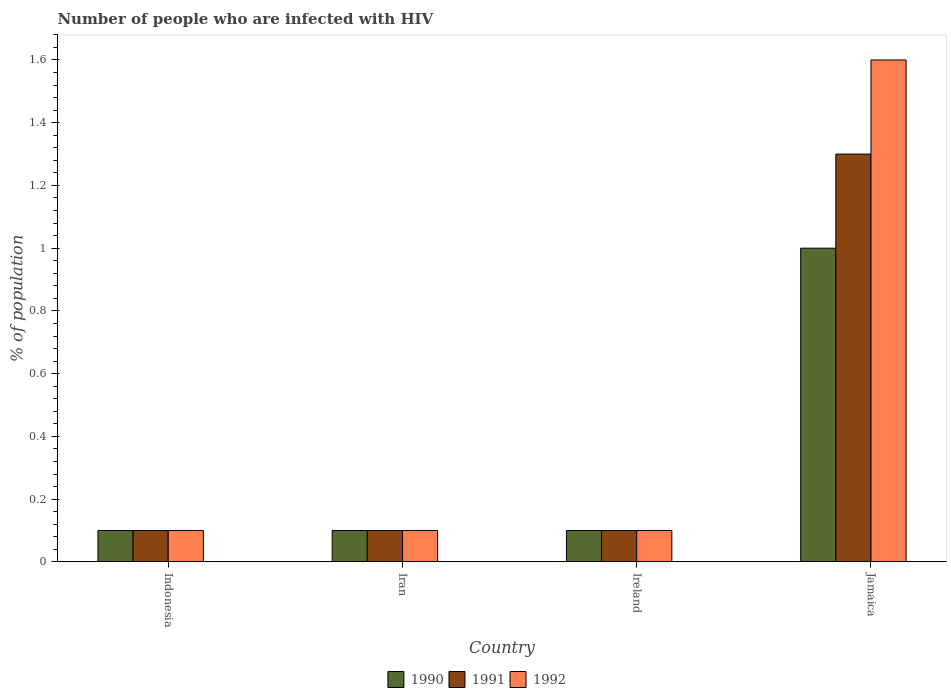How many different coloured bars are there?
Ensure brevity in your answer.  3. How many bars are there on the 4th tick from the right?
Ensure brevity in your answer.  3. What is the label of the 4th group of bars from the left?
Provide a short and direct response. Jamaica. In how many cases, is the number of bars for a given country not equal to the number of legend labels?
Offer a very short reply. 0. Across all countries, what is the minimum percentage of HIV infected population in in 1990?
Provide a succinct answer. 0.1. In which country was the percentage of HIV infected population in in 1992 maximum?
Provide a short and direct response. Jamaica. What is the total percentage of HIV infected population in in 1990 in the graph?
Offer a very short reply. 1.3. What is the difference between the percentage of HIV infected population in in 1991 in Ireland and the percentage of HIV infected population in in 1992 in Indonesia?
Your answer should be compact. 0. What is the average percentage of HIV infected population in in 1991 per country?
Your answer should be very brief. 0.4. What is the difference between the percentage of HIV infected population in of/in 1992 and percentage of HIV infected population in of/in 1990 in Indonesia?
Ensure brevity in your answer.  0. In how many countries, is the percentage of HIV infected population in in 1991 greater than 0.28 %?
Provide a short and direct response. 1. What is the ratio of the percentage of HIV infected population in in 1991 in Indonesia to that in Jamaica?
Your answer should be very brief. 0.08. What is the difference between the highest and the second highest percentage of HIV infected population in in 1992?
Make the answer very short. -1.5. What is the difference between the highest and the lowest percentage of HIV infected population in in 1992?
Give a very brief answer. 1.5. In how many countries, is the percentage of HIV infected population in in 1990 greater than the average percentage of HIV infected population in in 1990 taken over all countries?
Your answer should be compact. 1. Is it the case that in every country, the sum of the percentage of HIV infected population in in 1991 and percentage of HIV infected population in in 1992 is greater than the percentage of HIV infected population in in 1990?
Provide a short and direct response. Yes. How many bars are there?
Make the answer very short. 12. How many countries are there in the graph?
Ensure brevity in your answer.  4. What is the difference between two consecutive major ticks on the Y-axis?
Give a very brief answer. 0.2. Does the graph contain grids?
Offer a very short reply. No. How many legend labels are there?
Offer a terse response. 3. What is the title of the graph?
Keep it short and to the point. Number of people who are infected with HIV. What is the label or title of the X-axis?
Ensure brevity in your answer.  Country. What is the label or title of the Y-axis?
Your response must be concise. % of population. What is the % of population of 1990 in Indonesia?
Provide a short and direct response. 0.1. What is the % of population of 1991 in Indonesia?
Offer a terse response. 0.1. What is the % of population in 1990 in Iran?
Provide a succinct answer. 0.1. What is the % of population in 1991 in Iran?
Make the answer very short. 0.1. What is the % of population in 1992 in Iran?
Offer a terse response. 0.1. What is the % of population in 1991 in Jamaica?
Provide a succinct answer. 1.3. What is the % of population of 1992 in Jamaica?
Make the answer very short. 1.6. Across all countries, what is the maximum % of population in 1991?
Give a very brief answer. 1.3. Across all countries, what is the minimum % of population of 1990?
Offer a terse response. 0.1. Across all countries, what is the minimum % of population of 1991?
Your response must be concise. 0.1. Across all countries, what is the minimum % of population in 1992?
Offer a terse response. 0.1. What is the total % of population in 1990 in the graph?
Keep it short and to the point. 1.3. What is the total % of population of 1991 in the graph?
Make the answer very short. 1.6. What is the difference between the % of population in 1990 in Indonesia and that in Iran?
Give a very brief answer. 0. What is the difference between the % of population of 1990 in Indonesia and that in Ireland?
Provide a succinct answer. 0. What is the difference between the % of population in 1991 in Indonesia and that in Ireland?
Your response must be concise. 0. What is the difference between the % of population of 1990 in Indonesia and that in Jamaica?
Provide a succinct answer. -0.9. What is the difference between the % of population in 1991 in Indonesia and that in Jamaica?
Offer a terse response. -1.2. What is the difference between the % of population of 1992 in Indonesia and that in Jamaica?
Keep it short and to the point. -1.5. What is the difference between the % of population of 1992 in Iran and that in Ireland?
Your answer should be very brief. 0. What is the difference between the % of population of 1990 in Ireland and that in Jamaica?
Give a very brief answer. -0.9. What is the difference between the % of population in 1991 in Ireland and that in Jamaica?
Provide a short and direct response. -1.2. What is the difference between the % of population of 1992 in Ireland and that in Jamaica?
Offer a very short reply. -1.5. What is the difference between the % of population of 1990 in Indonesia and the % of population of 1992 in Iran?
Give a very brief answer. 0. What is the difference between the % of population in 1991 in Indonesia and the % of population in 1992 in Ireland?
Your answer should be compact. 0. What is the difference between the % of population of 1990 in Indonesia and the % of population of 1991 in Jamaica?
Offer a very short reply. -1.2. What is the difference between the % of population of 1991 in Indonesia and the % of population of 1992 in Jamaica?
Offer a very short reply. -1.5. What is the difference between the % of population of 1991 in Iran and the % of population of 1992 in Ireland?
Provide a succinct answer. 0. What is the difference between the % of population in 1990 in Iran and the % of population in 1991 in Jamaica?
Your response must be concise. -1.2. What is the difference between the % of population in 1990 in Ireland and the % of population in 1991 in Jamaica?
Keep it short and to the point. -1.2. What is the difference between the % of population in 1991 in Ireland and the % of population in 1992 in Jamaica?
Your response must be concise. -1.5. What is the average % of population in 1990 per country?
Offer a very short reply. 0.33. What is the average % of population of 1991 per country?
Ensure brevity in your answer.  0.4. What is the average % of population of 1992 per country?
Keep it short and to the point. 0.47. What is the difference between the % of population of 1990 and % of population of 1991 in Indonesia?
Provide a short and direct response. 0. What is the difference between the % of population of 1990 and % of population of 1992 in Indonesia?
Your answer should be compact. 0. What is the difference between the % of population in 1990 and % of population in 1991 in Jamaica?
Ensure brevity in your answer.  -0.3. What is the ratio of the % of population of 1991 in Indonesia to that in Iran?
Keep it short and to the point. 1. What is the ratio of the % of population of 1991 in Indonesia to that in Ireland?
Your answer should be compact. 1. What is the ratio of the % of population of 1992 in Indonesia to that in Ireland?
Keep it short and to the point. 1. What is the ratio of the % of population of 1990 in Indonesia to that in Jamaica?
Keep it short and to the point. 0.1. What is the ratio of the % of population in 1991 in Indonesia to that in Jamaica?
Keep it short and to the point. 0.08. What is the ratio of the % of population of 1992 in Indonesia to that in Jamaica?
Your response must be concise. 0.06. What is the ratio of the % of population in 1990 in Iran to that in Ireland?
Make the answer very short. 1. What is the ratio of the % of population in 1991 in Iran to that in Ireland?
Keep it short and to the point. 1. What is the ratio of the % of population of 1992 in Iran to that in Ireland?
Keep it short and to the point. 1. What is the ratio of the % of population of 1990 in Iran to that in Jamaica?
Make the answer very short. 0.1. What is the ratio of the % of population of 1991 in Iran to that in Jamaica?
Your answer should be very brief. 0.08. What is the ratio of the % of population in 1992 in Iran to that in Jamaica?
Your answer should be very brief. 0.06. What is the ratio of the % of population of 1991 in Ireland to that in Jamaica?
Your answer should be compact. 0.08. What is the ratio of the % of population of 1992 in Ireland to that in Jamaica?
Give a very brief answer. 0.06. What is the difference between the highest and the second highest % of population in 1990?
Provide a succinct answer. 0.9. What is the difference between the highest and the second highest % of population in 1992?
Make the answer very short. 1.5. What is the difference between the highest and the lowest % of population in 1990?
Provide a short and direct response. 0.9. What is the difference between the highest and the lowest % of population in 1991?
Your answer should be very brief. 1.2. 